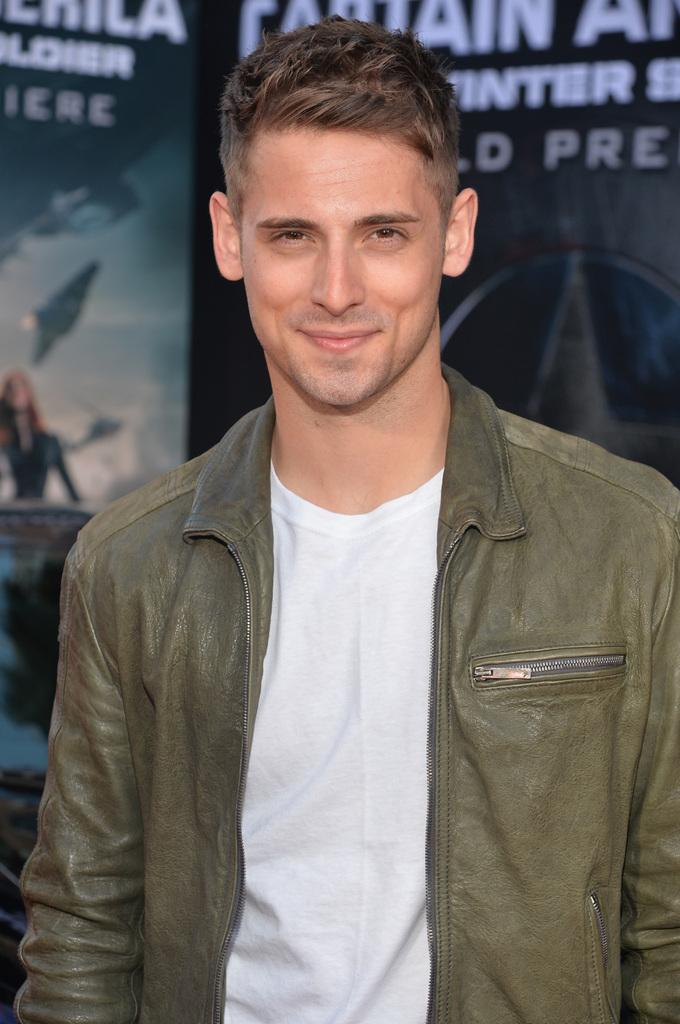What is the main subject of the image? There is a man standing in the image. What is the man wearing? The man is wearing a jacket. Where is the man located in the image? The man is in the middle of the image. What can be seen in the background of the image? There is a wall poster in the background of the image. What type of roof can be seen on the building in the image? There is no building or roof visible in the image; it only features a man standing and a wall poster in the background. 